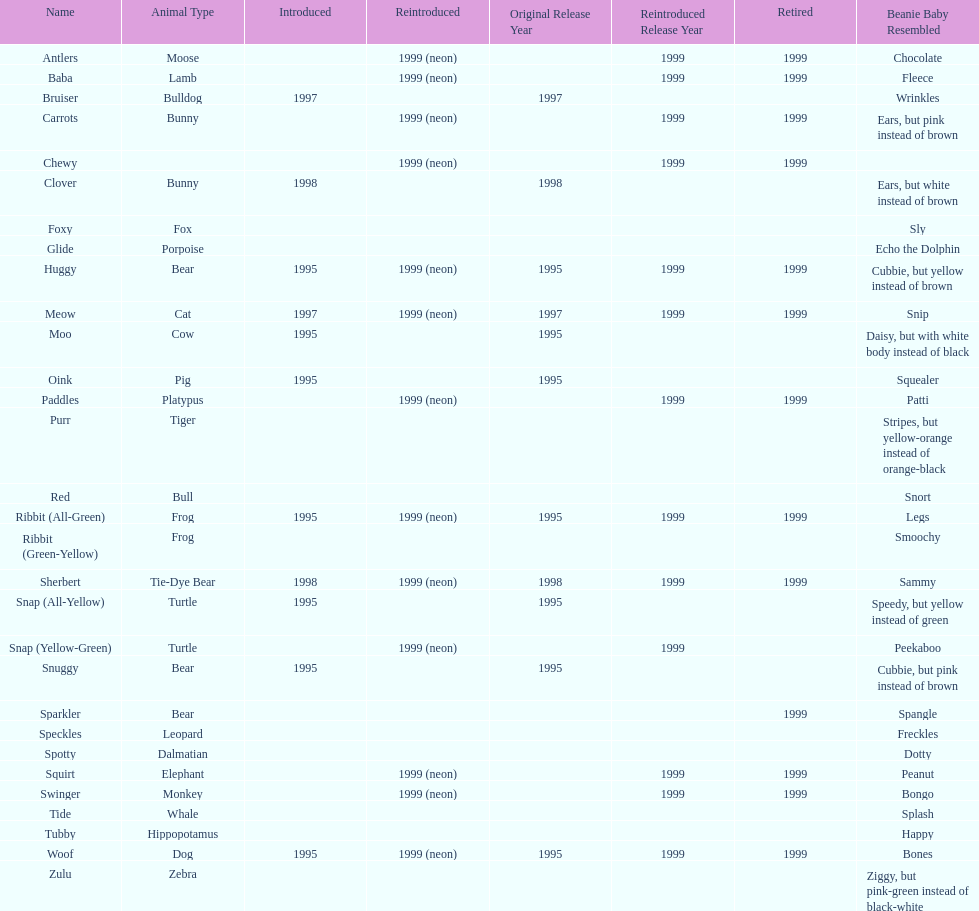What is the total number of pillow pals that were reintroduced as a neon variety? 13. 